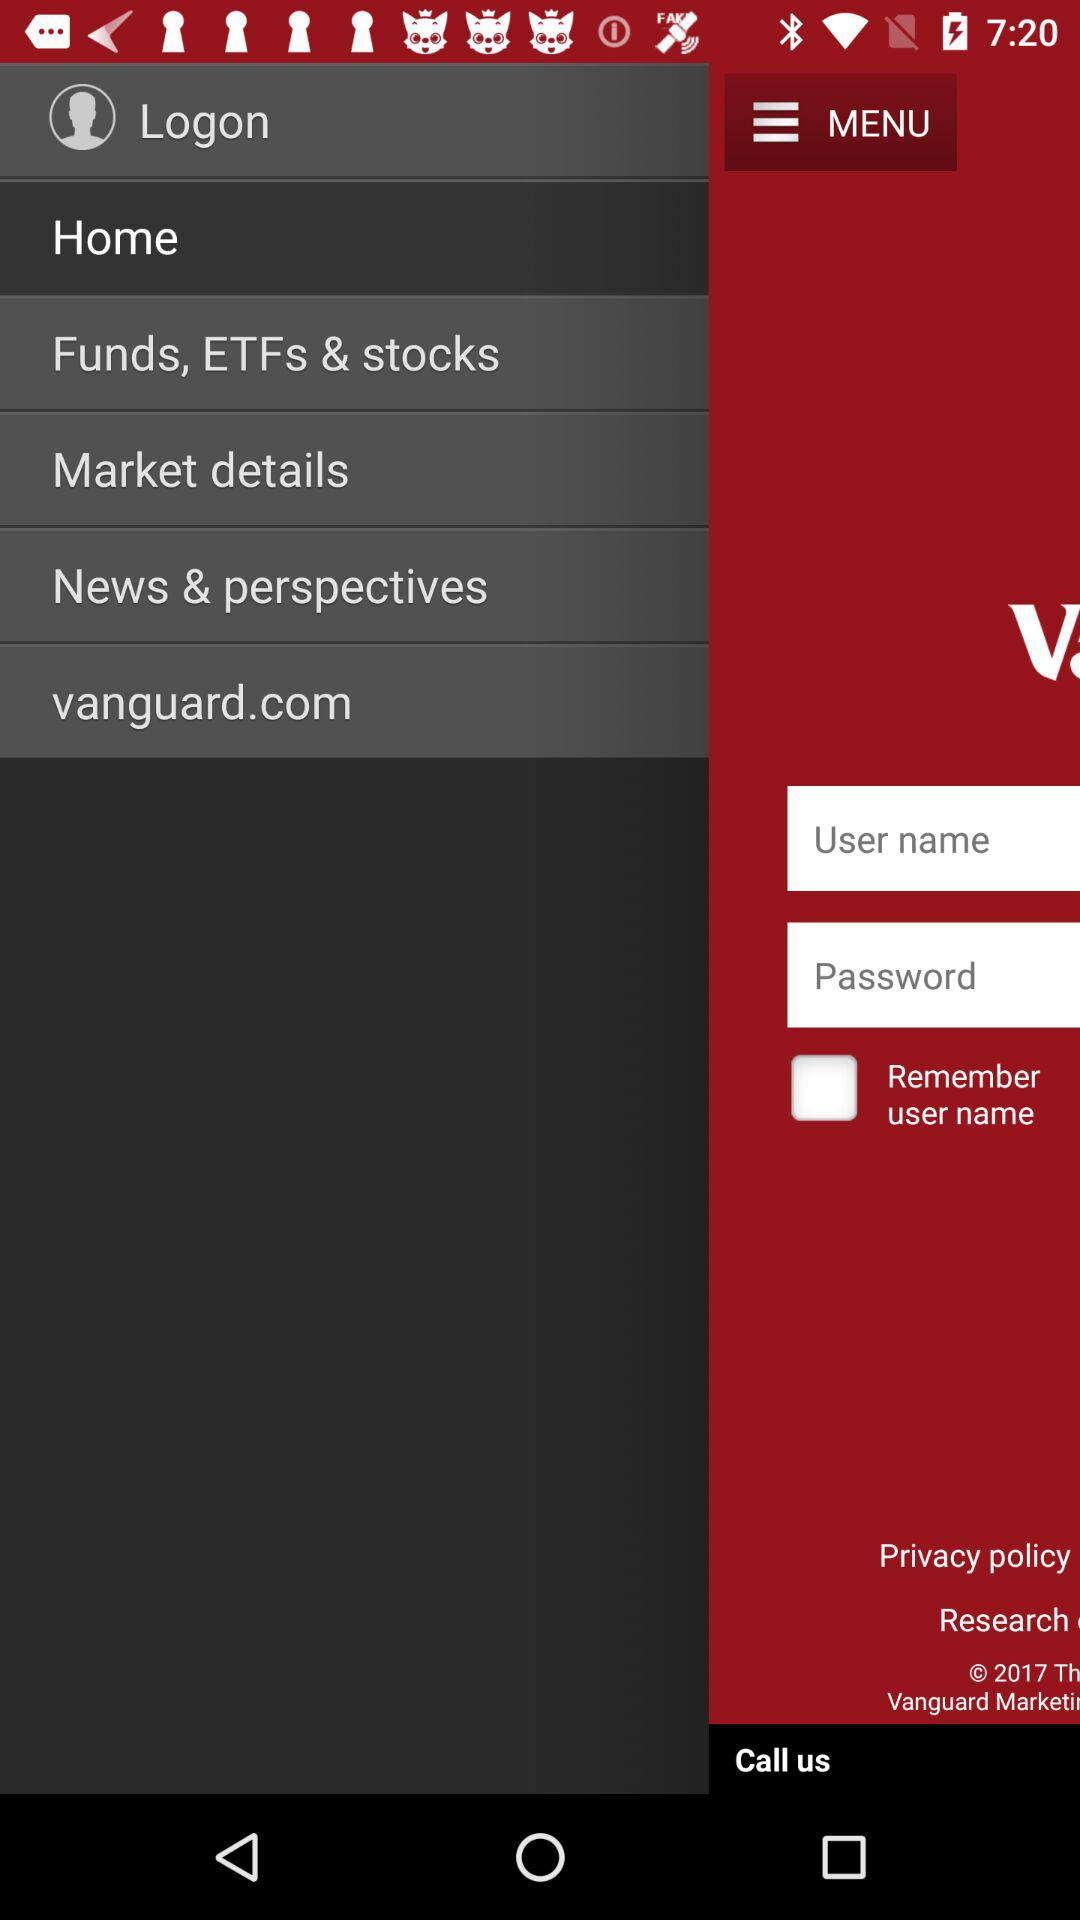How many text inputs are not required?
Answer the question using a single word or phrase. 1 